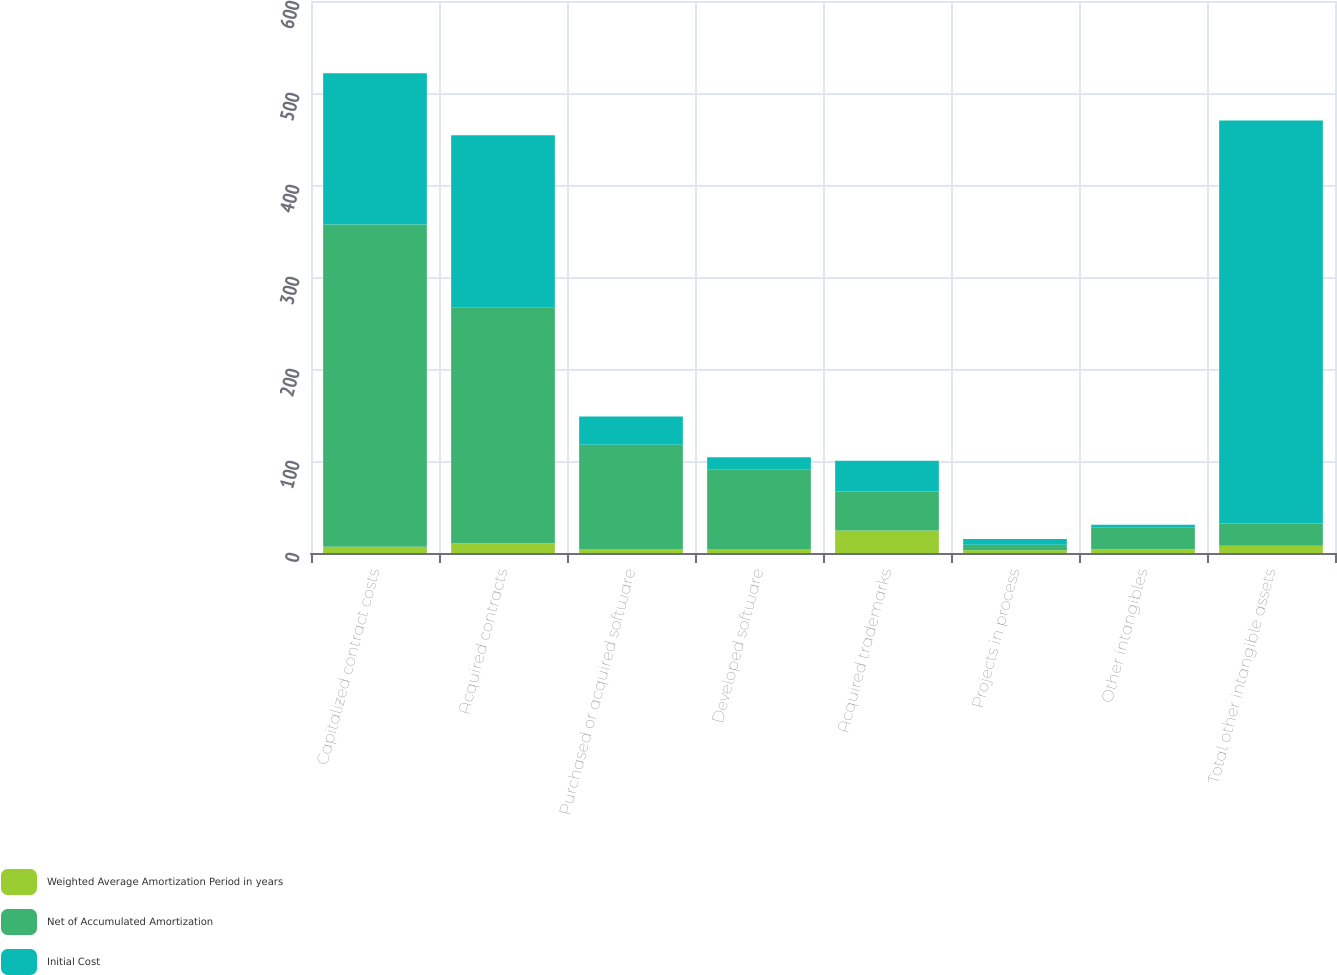Convert chart. <chart><loc_0><loc_0><loc_500><loc_500><stacked_bar_chart><ecel><fcel>Capitalized contract costs<fcel>Acquired contracts<fcel>Purchased or acquired software<fcel>Developed software<fcel>Acquired trademarks<fcel>Projects in process<fcel>Other intangibles<fcel>Total other intangible assets<nl><fcel>Weighted Average Amortization Period in years<fcel>6.7<fcel>10.7<fcel>3.7<fcel>4.3<fcel>24.5<fcel>3<fcel>4.1<fcel>8<nl><fcel>Net of Accumulated Amortization<fcel>350.3<fcel>256.5<fcel>113.9<fcel>86.1<fcel>42.3<fcel>6.1<fcel>24<fcel>24<nl><fcel>Initial Cost<fcel>164.6<fcel>186.8<fcel>30.7<fcel>13.7<fcel>33.4<fcel>6.1<fcel>2.7<fcel>438<nl></chart> 